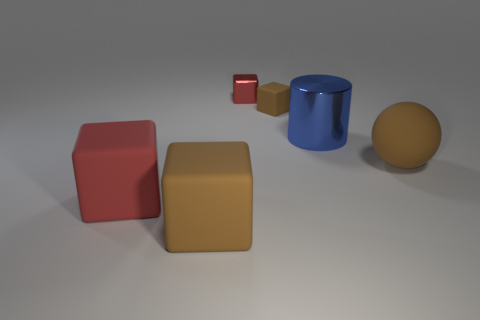What number of brown rubber cubes have the same size as the blue object?
Offer a very short reply. 1. There is a big brown thing that is the same shape as the tiny brown rubber object; what is its material?
Ensure brevity in your answer.  Rubber. How many objects are matte balls that are in front of the blue cylinder or brown blocks to the right of the tiny metal block?
Your response must be concise. 2. Does the tiny rubber object have the same shape as the object to the right of the big blue metallic cylinder?
Keep it short and to the point. No. There is a big matte object behind the matte thing left of the brown matte cube in front of the sphere; what shape is it?
Keep it short and to the point. Sphere. How many other objects are the same material as the large red cube?
Offer a terse response. 3. How many things are big matte things that are right of the red shiny block or tiny brown blocks?
Your answer should be compact. 2. There is a brown object behind the large object on the right side of the large metallic cylinder; what shape is it?
Provide a short and direct response. Cube. Does the tiny thing that is behind the small rubber cube have the same shape as the large blue metal thing?
Offer a very short reply. No. What color is the large rubber cube behind the big brown block?
Keep it short and to the point. Red. 